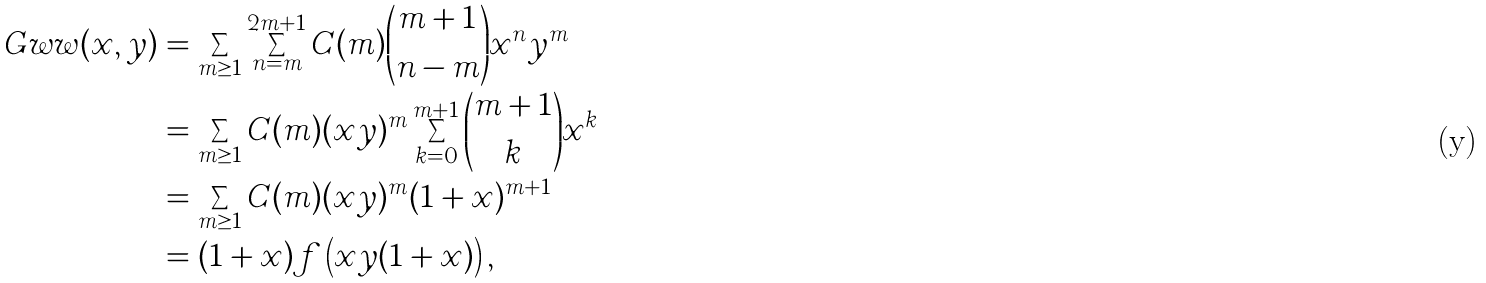Convert formula to latex. <formula><loc_0><loc_0><loc_500><loc_500>\ G w w ( x , y ) & = \sum _ { m \geq 1 } \sum _ { n = m } ^ { 2 m + 1 } C ( m ) \binom { m + 1 } { n - m } x ^ { n } y ^ { m } \\ & = \sum _ { m \geq 1 } C ( m ) ( x y ) ^ { m } \sum _ { k = 0 } ^ { m + 1 } \binom { m + 1 } { k } x ^ { k } \\ & = \sum _ { m \geq 1 } C ( m ) ( x y ) ^ { m } ( 1 + x ) ^ { m + 1 } \\ & = ( 1 + x ) f \left ( x y ( 1 + x ) \right ) ,</formula> 